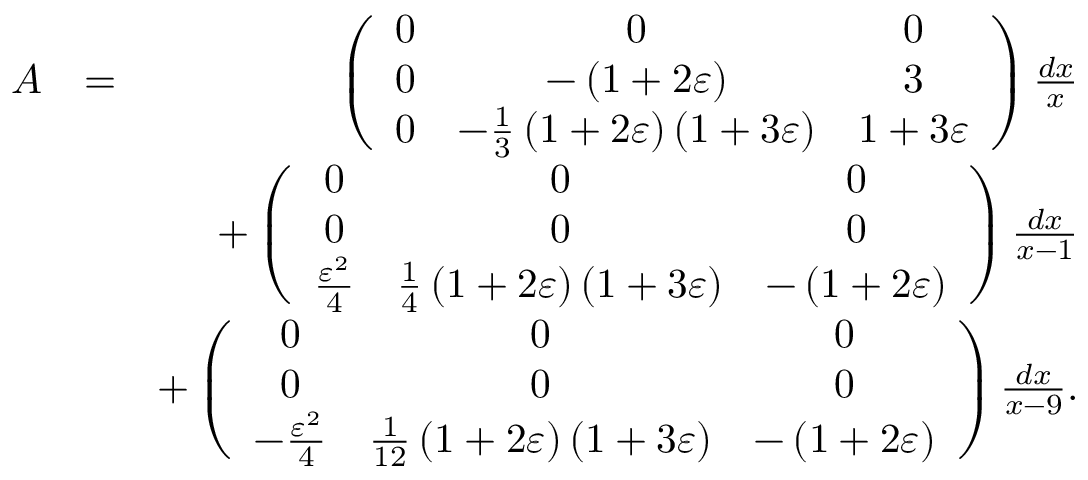Convert formula to latex. <formula><loc_0><loc_0><loc_500><loc_500>\begin{array} { r l r } { A } & { = } & { \left ( \begin{array} { c c c } { 0 } & { 0 } & { 0 } \\ { 0 } & { - \left ( 1 + 2 \varepsilon \right ) } & { 3 } \\ { 0 } & { - \frac { 1 } { 3 } \left ( 1 + 2 \varepsilon \right ) \left ( 1 + 3 \varepsilon \right ) } & { 1 + 3 \varepsilon } \end{array} \right ) \frac { d x } { x } } \\ & { + \left ( \begin{array} { c c c } { 0 } & { 0 } & { 0 } \\ { 0 } & { 0 } & { 0 } \\ { \frac { \varepsilon ^ { 2 } } { 4 } } & { \frac { 1 } { 4 } \left ( 1 + 2 \varepsilon \right ) \left ( 1 + 3 \varepsilon \right ) } & { - \left ( 1 + 2 \varepsilon \right ) } \end{array} \right ) \frac { d x } { x - 1 } } \\ & { + \left ( \begin{array} { c c c } { 0 } & { 0 } & { 0 } \\ { 0 } & { 0 } & { 0 } \\ { - \frac { \varepsilon ^ { 2 } } { 4 } } & { \frac { 1 } { 1 2 } \left ( 1 + 2 \varepsilon \right ) \left ( 1 + 3 \varepsilon \right ) } & { - \left ( 1 + 2 \varepsilon \right ) } \end{array} \right ) \frac { d x } { x - 9 } . } \end{array}</formula> 